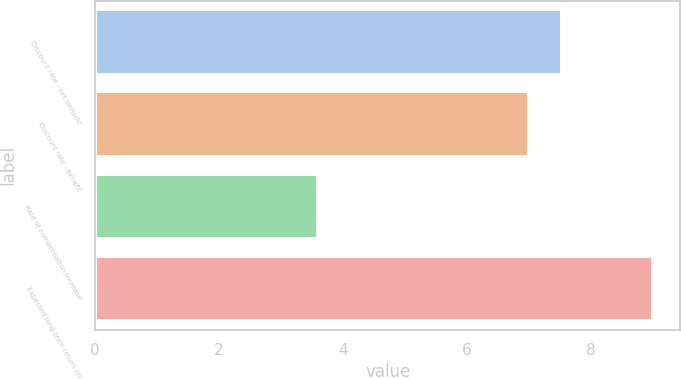Convert chart to OTSL. <chart><loc_0><loc_0><loc_500><loc_500><bar_chart><fcel>Discount rate - net periodic<fcel>Discount rate - benefit<fcel>Rate of compensation increase<fcel>Expected long-term return on<nl><fcel>7.54<fcel>7<fcel>3.6<fcel>9<nl></chart> 